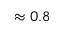<formula> <loc_0><loc_0><loc_500><loc_500>\approx 0 . 8</formula> 